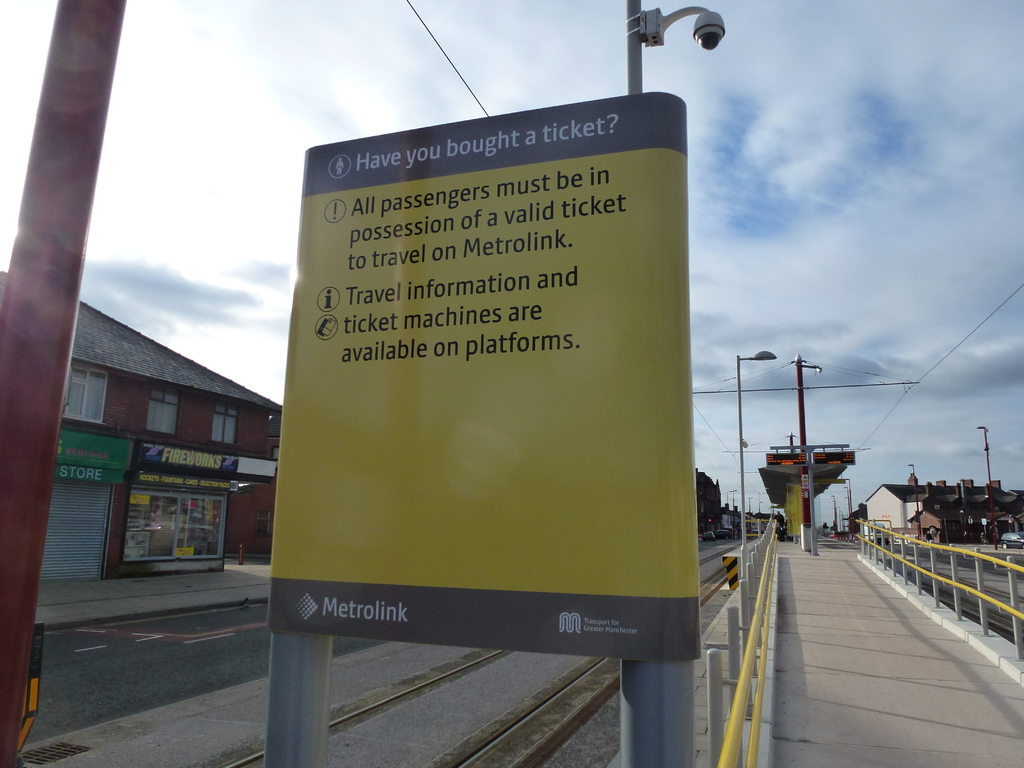Can you tell me more about the shops visible in the background of this image? Certainly! The image shows a variety of small shops located directly across from the Metrolink station. Notably, there is a store advertising fireworks, which suggests a local business possibly catering to seasonal events or celebrations. These shops add a commercial element to the area, indicating a neighborhood that blends transportation amenities with retail opportunities, thereby serving both commuting and shopping needs of the local residents. 